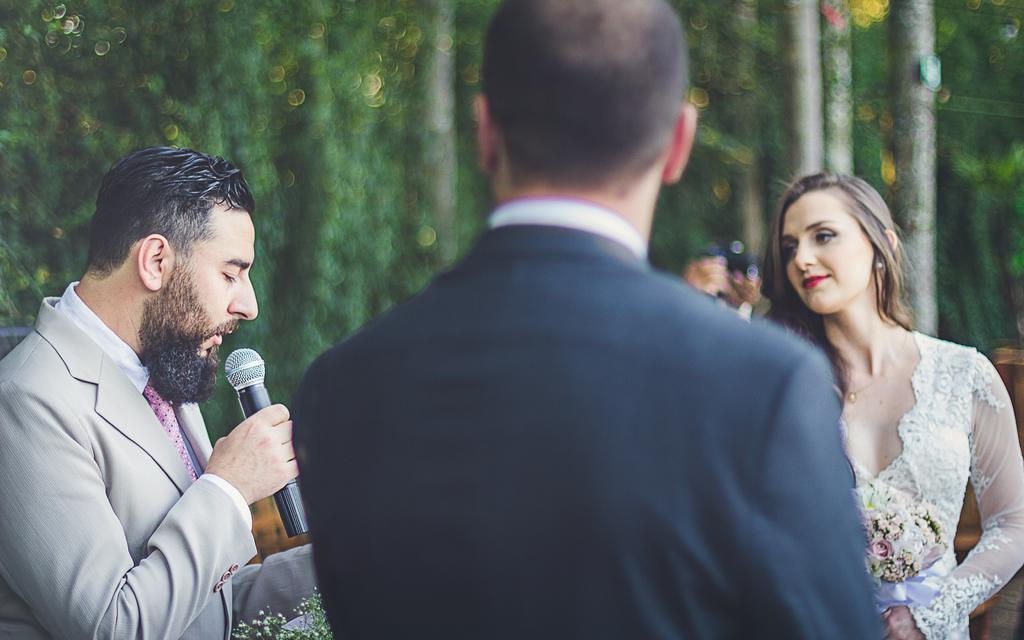What is the main subject of the image? The main subject of the image is a group of people. Where are the people located in the image? The group of people is on the left side of the image. What is the man in the group holding? The man is holding a microphone in his hand. What can be seen in the background of the image? There are trees visible in the background of the image. What type of van can be seen parked near the group of people in the image? There is no van present in the image; it only features a group of people, a man holding a microphone, and trees in the background. 